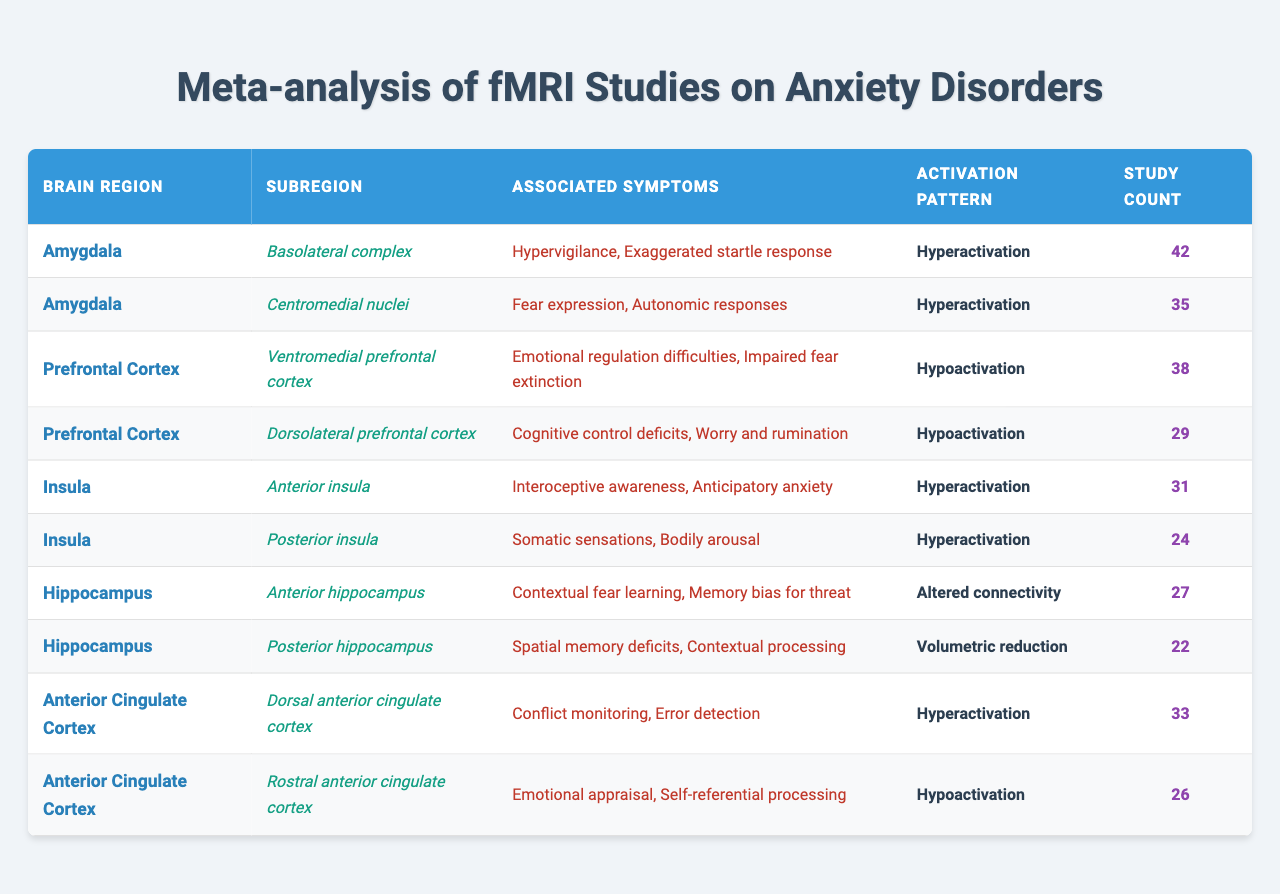What is the activation pattern associated with the basolateral complex of the amygdala? According to the table, the basolateral complex of the amygdala has an activation pattern of "Hyperactivation."
Answer: Hyperactivation Which brain region has the most subregions? The table shows that the amygdala has two subregions (basolateral complex, centromedial nuclei), which is the highest count among all brain regions listed.
Answer: Amygdala How many study counts are associated with the dorsal anterior cingulate cortex? From the table, it can be observed that the dorsal anterior cingulate cortex has a study count of 33.
Answer: 33 What percentage of study counts are associated with the amygdala in total? The amygdala has a total study count of 77 (42 for basolateral complex + 35 for centromedial nuclei). The total study counts across all regions are 42 + 35 + 38 + 29 + 31 + 24 + 27 + 22 + 33 + 26 =  357. The percentage is (77/357) * 100 = 21.56%.
Answer: 21.56% Is the emotional regulation difficulties symptom linked with hypoactivation or hyperactivation? According to the table, emotional regulation difficulties are listed under the ventromedial prefrontal cortex, which has a hypoactivation pattern.
Answer: Hypoactivation What is the total number of studies for all subregions of the insula? The anterior insula has a count of 31 and the posterior insula has a count of 24. Summing these gives a total of 31 + 24 = 55 studies for all insula subregions.
Answer: 55 Which subregion has the lowest study count and what is its associated symptom? The posterior hippocampus has the lowest study count of 22, and its associated symptoms include "Spatial memory deficits" and "Contextual processing."
Answer: 22; "Spatial memory deficits, Contextual processing" Identify the brain region with the highest average study count across its subregions. The average study count for the amygdala is (42 + 35) / 2 = 38.5, for the prefrontal cortex is (38 + 29) / 2 = 33.5, for the insula is (31 + 24) / 2 = 27.5, for the hippocampus is (27 + 22) / 2 = 24.5, and for the anterior cingulate cortex is (33 + 26) / 2 = 29.5. The amygdala has the highest average.
Answer: Amygdala Are there any symptoms associated with hypoactivation that link with "Worry"? The subregion associated with "Worry and rumination" is the dorsolateral prefrontal cortex, which exhibits hypoactivation as per the table.
Answer: Yes How many total different activation patterns are recorded in the table? The unique activation patterns in the table are "Hyperactivation," "Hypoactivation," "Altered connectivity," and "Volumetric reduction," totaling four different patterns.
Answer: 4 